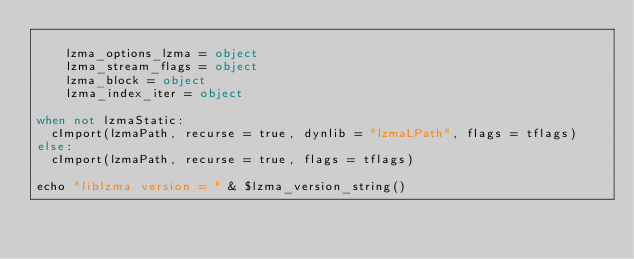Convert code to text. <code><loc_0><loc_0><loc_500><loc_500><_Nim_>
    lzma_options_lzma = object
    lzma_stream_flags = object
    lzma_block = object
    lzma_index_iter = object

when not lzmaStatic:
  cImport(lzmaPath, recurse = true, dynlib = "lzmaLPath", flags = tflags)
else:
  cImport(lzmaPath, recurse = true, flags = tflags)

echo "liblzma version = " & $lzma_version_string()
</code> 